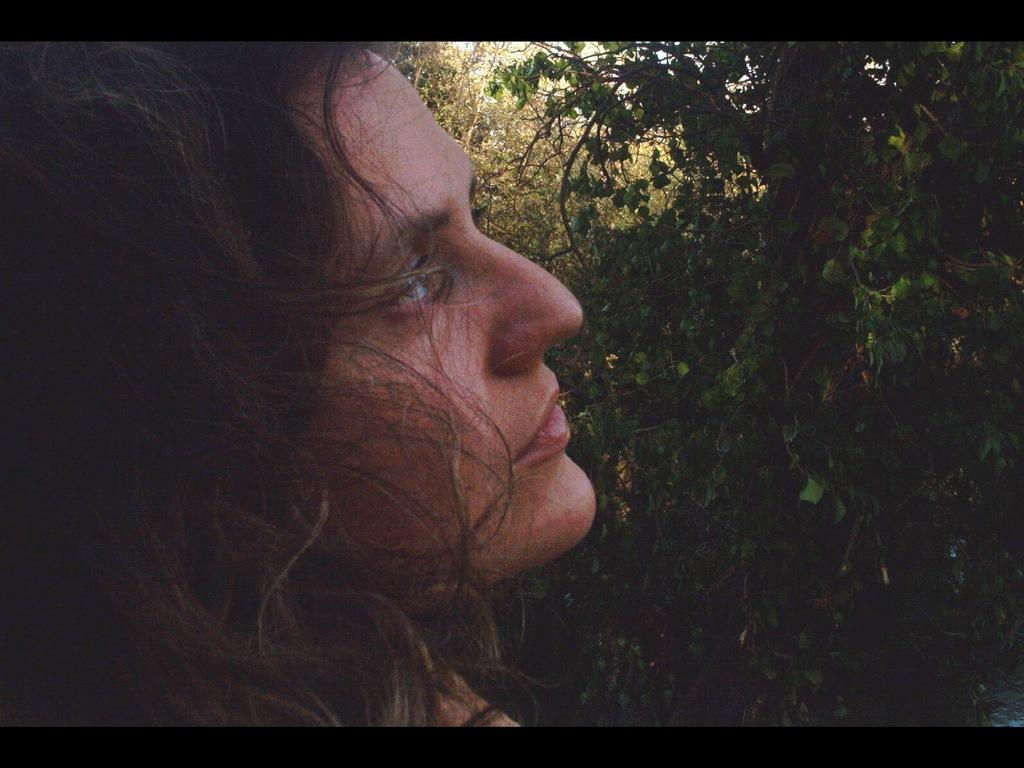Who is the main subject in the image? There is a woman in the image. Where is the woman located in the image? The woman is in the front of the image. What can be seen in the background of the image? There are trees in the background of the image. What committee is the woman addressing in the image? There is no committee present in the image; it only features a woman in the front and trees in the background. 